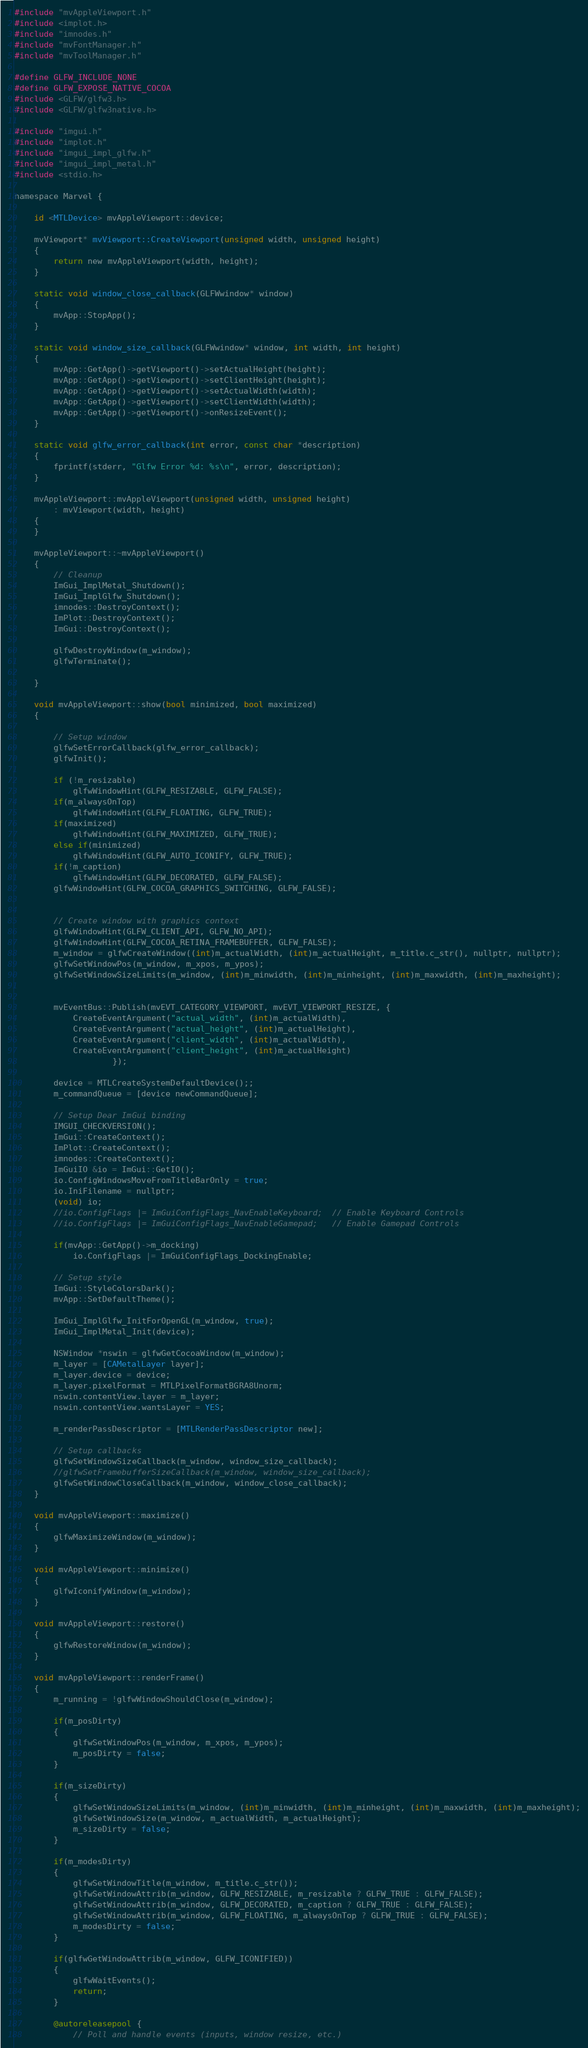<code> <loc_0><loc_0><loc_500><loc_500><_ObjectiveC_>#include "mvAppleViewport.h"
#include <implot.h>
#include "imnodes.h"
#include "mvFontManager.h"
#include "mvToolManager.h"

#define GLFW_INCLUDE_NONE
#define GLFW_EXPOSE_NATIVE_COCOA
#include <GLFW/glfw3.h>
#include <GLFW/glfw3native.h>

#include "imgui.h"
#include "implot.h"
#include "imgui_impl_glfw.h"
#include "imgui_impl_metal.h"
#include <stdio.h>

namespace Marvel {

    id <MTLDevice> mvAppleViewport::device;

    mvViewport* mvViewport::CreateViewport(unsigned width, unsigned height)
	{
		return new mvAppleViewport(width, height);
	}

    static void window_close_callback(GLFWwindow* window)
    {
        mvApp::StopApp();
    }

    static void window_size_callback(GLFWwindow* window, int width, int height)
    {
        mvApp::GetApp()->getViewport()->setActualHeight(height);
        mvApp::GetApp()->getViewport()->setClientHeight(height);
        mvApp::GetApp()->getViewport()->setActualWidth(width);
        mvApp::GetApp()->getViewport()->setClientWidth(width);
        mvApp::GetApp()->getViewport()->onResizeEvent();
    }

    static void glfw_error_callback(int error, const char *description)
    {
        fprintf(stderr, "Glfw Error %d: %s\n", error, description);
    }

    mvAppleViewport::mvAppleViewport(unsigned width, unsigned height)
        : mvViewport(width, height)
    {
    }

    mvAppleViewport::~mvAppleViewport()
    {
        // Cleanup
        ImGui_ImplMetal_Shutdown();
        ImGui_ImplGlfw_Shutdown();
        imnodes::DestroyContext();
        ImPlot::DestroyContext();
        ImGui::DestroyContext();

        glfwDestroyWindow(m_window);
        glfwTerminate();

    }

    void mvAppleViewport::show(bool minimized, bool maximized)
    {

        // Setup window
        glfwSetErrorCallback(glfw_error_callback);
        glfwInit();

        if (!m_resizable)
            glfwWindowHint(GLFW_RESIZABLE, GLFW_FALSE);
        if(m_alwaysOnTop)
            glfwWindowHint(GLFW_FLOATING, GLFW_TRUE);
        if(maximized)
            glfwWindowHint(GLFW_MAXIMIZED, GLFW_TRUE);
        else if(minimized)
            glfwWindowHint(GLFW_AUTO_ICONIFY, GLFW_TRUE);
        if(!m_caption)
            glfwWindowHint(GLFW_DECORATED, GLFW_FALSE);
        glfwWindowHint(GLFW_COCOA_GRAPHICS_SWITCHING, GLFW_FALSE);


        // Create window with graphics context
        glfwWindowHint(GLFW_CLIENT_API, GLFW_NO_API);
        glfwWindowHint(GLFW_COCOA_RETINA_FRAMEBUFFER, GLFW_FALSE);
        m_window = glfwCreateWindow((int)m_actualWidth, (int)m_actualHeight, m_title.c_str(), nullptr, nullptr);
        glfwSetWindowPos(m_window, m_xpos, m_ypos);
        glfwSetWindowSizeLimits(m_window, (int)m_minwidth, (int)m_minheight, (int)m_maxwidth, (int)m_maxheight);


        mvEventBus::Publish(mvEVT_CATEGORY_VIEWPORT, mvEVT_VIEWPORT_RESIZE, {
            CreateEventArgument("actual_width", (int)m_actualWidth),
            CreateEventArgument("actual_height", (int)m_actualHeight),
            CreateEventArgument("client_width", (int)m_actualWidth),
            CreateEventArgument("client_height", (int)m_actualHeight)
                    });

        device = MTLCreateSystemDefaultDevice();;
        m_commandQueue = [device newCommandQueue];

        // Setup Dear ImGui binding
        IMGUI_CHECKVERSION();
        ImGui::CreateContext();
        ImPlot::CreateContext();
        imnodes::CreateContext();
        ImGuiIO &io = ImGui::GetIO();
        io.ConfigWindowsMoveFromTitleBarOnly = true;
        io.IniFilename = nullptr;
        (void) io;
        //io.ConfigFlags |= ImGuiConfigFlags_NavEnableKeyboard;  // Enable Keyboard Controls
        //io.ConfigFlags |= ImGuiConfigFlags_NavEnableGamepad;   // Enable Gamepad Controls

        if(mvApp::GetApp()->m_docking)
            io.ConfigFlags |= ImGuiConfigFlags_DockingEnable;

        // Setup style
        ImGui::StyleColorsDark();
        mvApp::SetDefaultTheme();

        ImGui_ImplGlfw_InitForOpenGL(m_window, true);
        ImGui_ImplMetal_Init(device);

        NSWindow *nswin = glfwGetCocoaWindow(m_window);
        m_layer = [CAMetalLayer layer];
        m_layer.device = device;
        m_layer.pixelFormat = MTLPixelFormatBGRA8Unorm;
        nswin.contentView.layer = m_layer;
        nswin.contentView.wantsLayer = YES;

        m_renderPassDescriptor = [MTLRenderPassDescriptor new];

        // Setup callbacks
        glfwSetWindowSizeCallback(m_window, window_size_callback);
        //glfwSetFramebufferSizeCallback(m_window, window_size_callback);
        glfwSetWindowCloseCallback(m_window, window_close_callback);
    }

    void mvAppleViewport::maximize()
	{
        glfwMaximizeWindow(m_window);
	}

	void mvAppleViewport::minimize()
	{
        glfwIconifyWindow(m_window);
	}

    void mvAppleViewport::restore()
    {
        glfwRestoreWindow(m_window);
    }

    void mvAppleViewport::renderFrame()
    {
        m_running = !glfwWindowShouldClose(m_window);

        if(m_posDirty)
        {
            glfwSetWindowPos(m_window, m_xpos, m_ypos);
            m_posDirty = false;
        }

        if(m_sizeDirty)
        {
            glfwSetWindowSizeLimits(m_window, (int)m_minwidth, (int)m_minheight, (int)m_maxwidth, (int)m_maxheight);
            glfwSetWindowSize(m_window, m_actualWidth, m_actualHeight);
            m_sizeDirty = false;
        }

        if(m_modesDirty)
        {
            glfwSetWindowTitle(m_window, m_title.c_str());
            glfwSetWindowAttrib(m_window, GLFW_RESIZABLE, m_resizable ? GLFW_TRUE : GLFW_FALSE);
            glfwSetWindowAttrib(m_window, GLFW_DECORATED, m_caption ? GLFW_TRUE : GLFW_FALSE);
            glfwSetWindowAttrib(m_window, GLFW_FLOATING, m_alwaysOnTop ? GLFW_TRUE : GLFW_FALSE);
            m_modesDirty = false;
        }

        if(glfwGetWindowAttrib(m_window, GLFW_ICONIFIED))
        {
            glfwWaitEvents();
            return;
        }

        @autoreleasepool {
            // Poll and handle events (inputs, window resize, etc.)</code> 